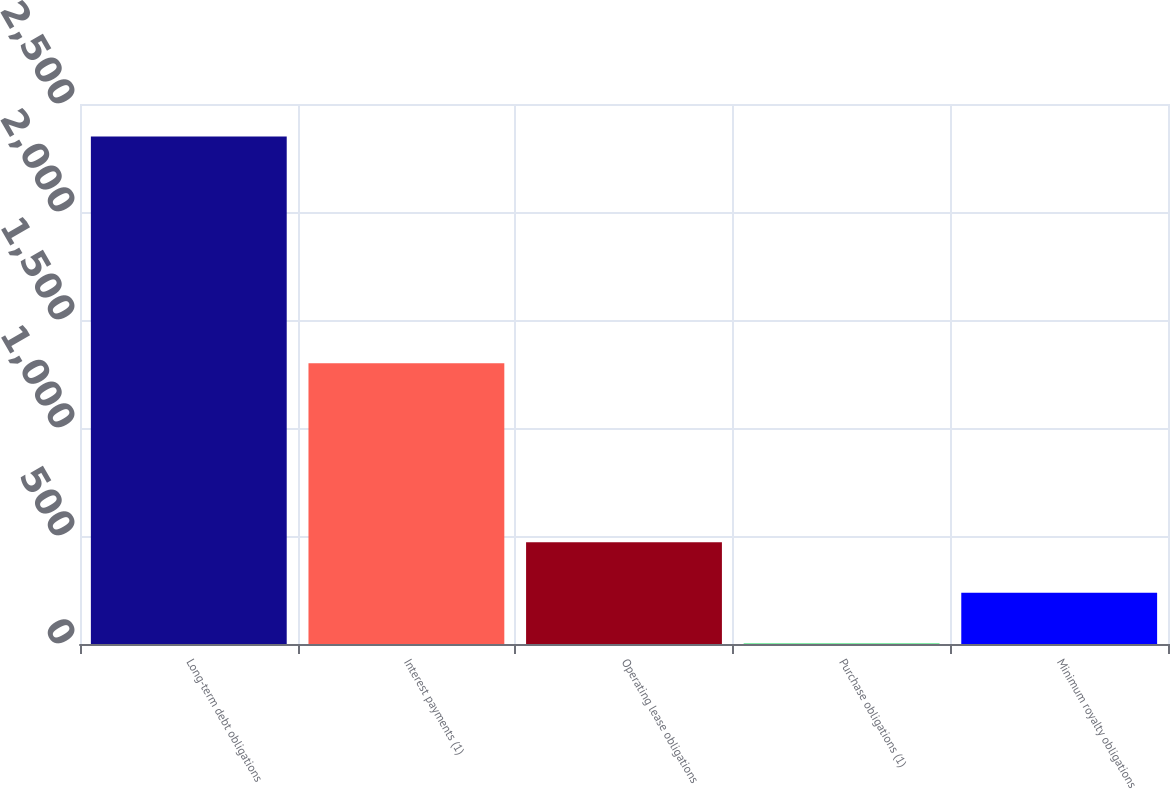Convert chart to OTSL. <chart><loc_0><loc_0><loc_500><loc_500><bar_chart><fcel>Long-term debt obligations<fcel>Interest payments (1)<fcel>Operating lease obligations<fcel>Purchase obligations (1)<fcel>Minimum royalty obligations<nl><fcel>2350<fcel>1300<fcel>471.6<fcel>2<fcel>236.8<nl></chart> 